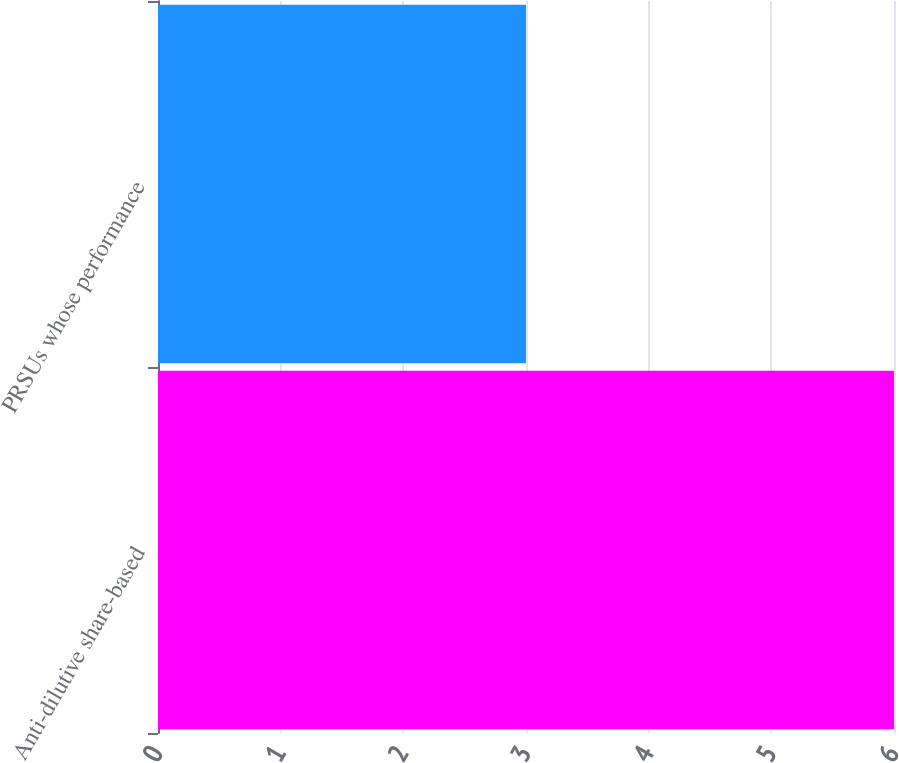Convert chart. <chart><loc_0><loc_0><loc_500><loc_500><bar_chart><fcel>Anti-dilutive share-based<fcel>PRSUs whose performance<nl><fcel>6<fcel>3<nl></chart> 